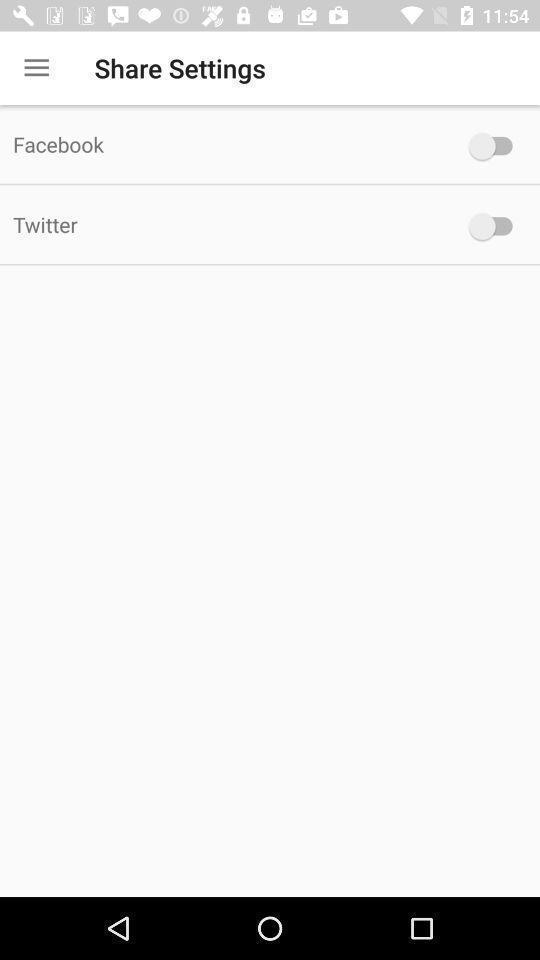Tell me about the visual elements in this screen capture. Screen shows to share settings. 